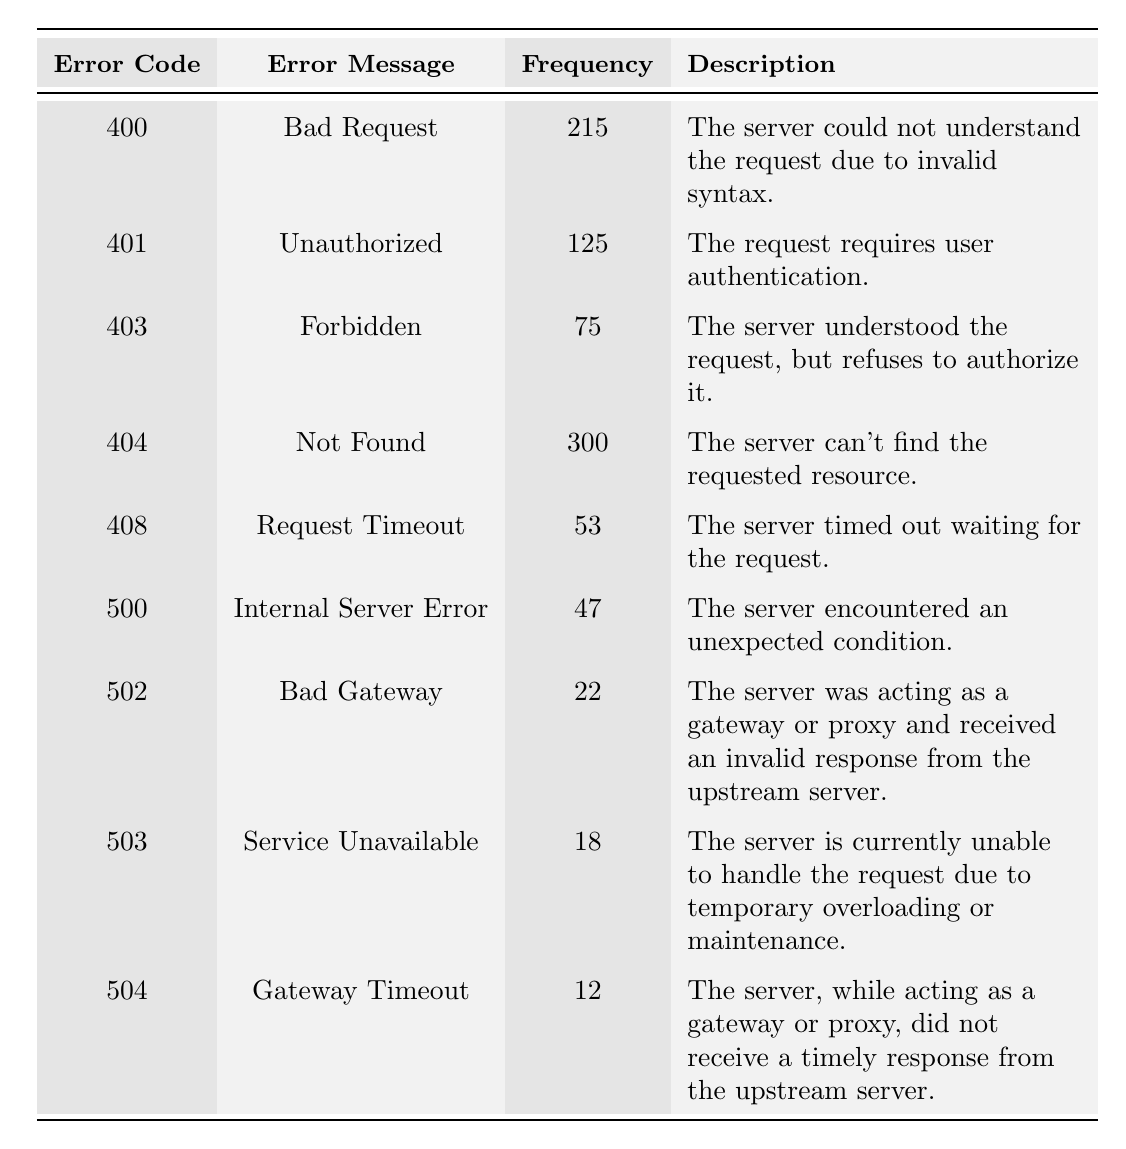What is the frequency of the error code 404? The error code 404 has a frequency of 300, as directly stated in the table.
Answer: 300 Which error code has the highest frequency? Comparing the frequencies listed in the table, error code 404 has the highest frequency at 300.
Answer: 404 How many error responses have a frequency greater than 100? By counting the error codes with a frequency greater than 100, we find that there are three: 400 (215), 401 (125), and 404 (300).
Answer: 3 What is the combined frequency of the error codes 500 and 503? Adding the frequencies of error codes 500 (47) and 503 (18) gives us 47 + 18 = 65.
Answer: 65 Is there an error code that has a frequency of less than 20? Reviewing the table, the error code with the lowest frequency is 504 (12), which is less than 20.
Answer: Yes What is the difference in frequency between the error codes 400 and 403? The frequency of error code 400 is 215 and that of 403 is 75. The difference is 215 - 75 = 140.
Answer: 140 What is the average frequency of all error codes listed? Summing all the frequencies: 215 + 125 + 75 + 300 + 53 + 47 + 22 + 18 + 12 = 867. There are 9 error codes, so the average is 867 / 9 ≈ 96.33.
Answer: 96.33 How many error codes have a frequency of 50 or less? The only error codes with a frequency of 50 or less are 500 (47), 502 (22), 503 (18), and 504 (12). This totals 4 codes.
Answer: 4 Which error code corresponds to "Bad Gateway"? The error message "Bad Gateway" corresponds to error code 502, as shown in the table.
Answer: 502 Is the error code 408 more frequent than 500? Error code 408 has a frequency of 53, which is more than the frequency of error code 500, which is 47.
Answer: Yes 